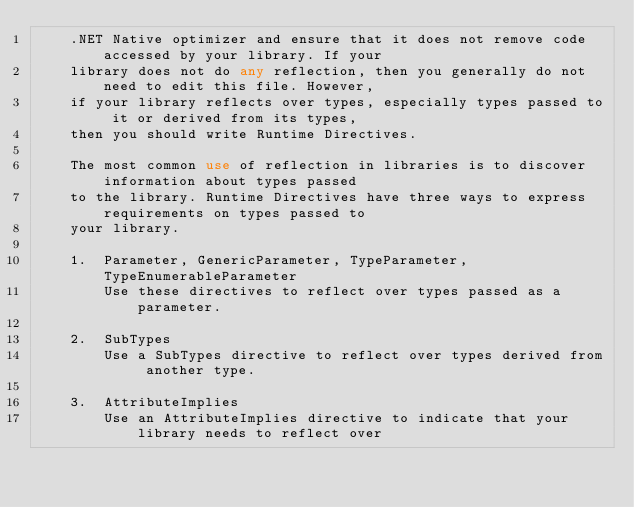Convert code to text. <code><loc_0><loc_0><loc_500><loc_500><_XML_>    .NET Native optimizer and ensure that it does not remove code accessed by your library. If your
    library does not do any reflection, then you generally do not need to edit this file. However,
    if your library reflects over types, especially types passed to it or derived from its types,
    then you should write Runtime Directives.

    The most common use of reflection in libraries is to discover information about types passed
    to the library. Runtime Directives have three ways to express requirements on types passed to
    your library.

    1.  Parameter, GenericParameter, TypeParameter, TypeEnumerableParameter
        Use these directives to reflect over types passed as a parameter.

    2.  SubTypes
        Use a SubTypes directive to reflect over types derived from another type.

    3.  AttributeImplies
        Use an AttributeImplies directive to indicate that your library needs to reflect over</code> 